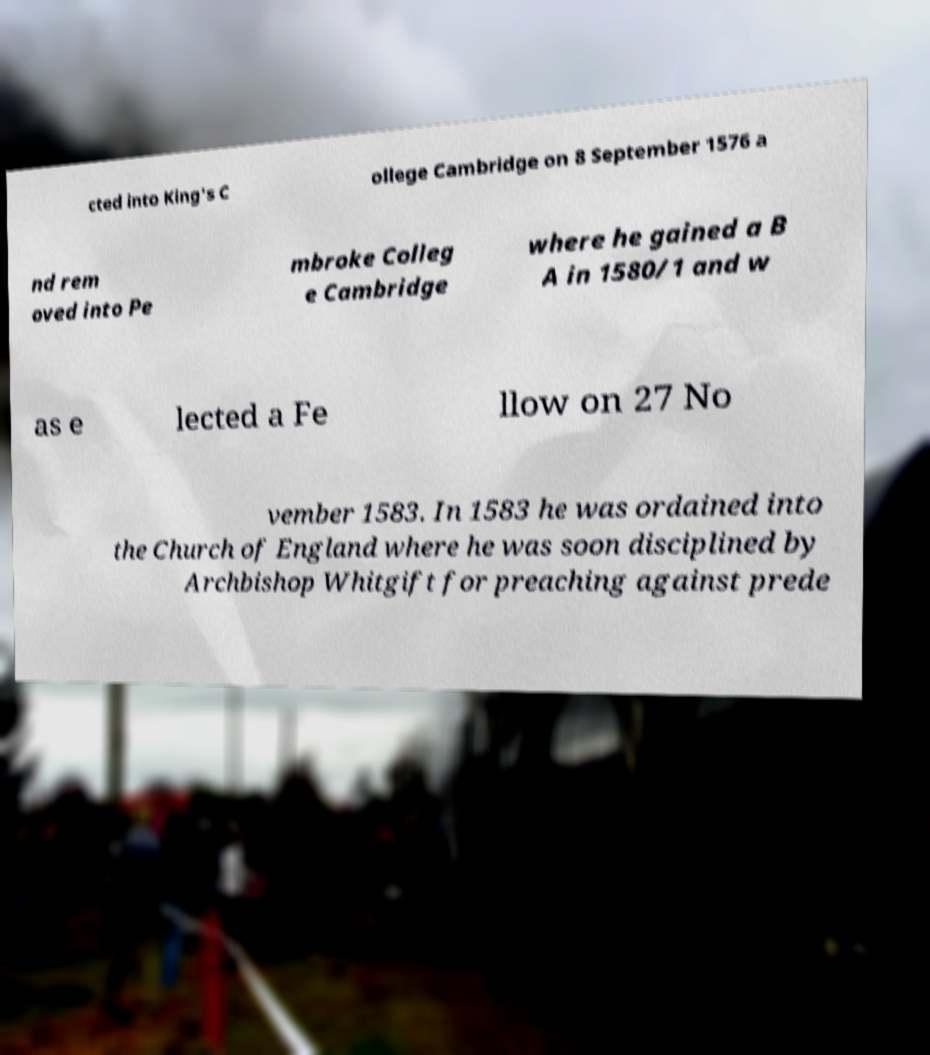Could you assist in decoding the text presented in this image and type it out clearly? cted into King's C ollege Cambridge on 8 September 1576 a nd rem oved into Pe mbroke Colleg e Cambridge where he gained a B A in 1580/1 and w as e lected a Fe llow on 27 No vember 1583. In 1583 he was ordained into the Church of England where he was soon disciplined by Archbishop Whitgift for preaching against prede 